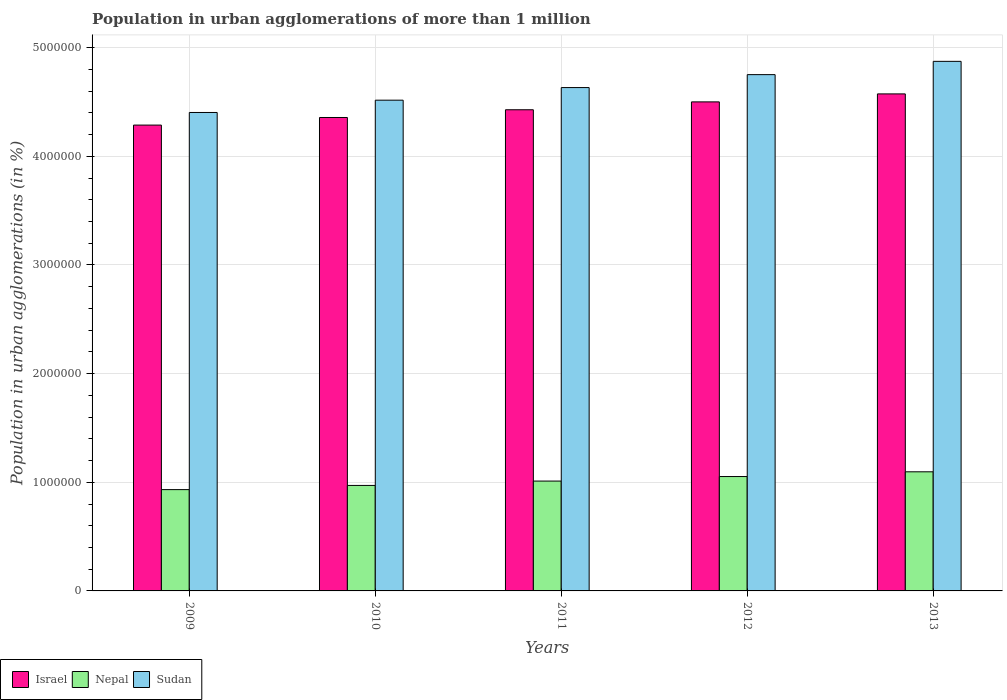How many different coloured bars are there?
Keep it short and to the point. 3. How many groups of bars are there?
Keep it short and to the point. 5. Are the number of bars per tick equal to the number of legend labels?
Offer a very short reply. Yes. What is the label of the 1st group of bars from the left?
Make the answer very short. 2009. In how many cases, is the number of bars for a given year not equal to the number of legend labels?
Your answer should be compact. 0. What is the population in urban agglomerations in Israel in 2010?
Provide a short and direct response. 4.36e+06. Across all years, what is the maximum population in urban agglomerations in Nepal?
Ensure brevity in your answer.  1.10e+06. Across all years, what is the minimum population in urban agglomerations in Israel?
Ensure brevity in your answer.  4.29e+06. In which year was the population in urban agglomerations in Israel maximum?
Offer a terse response. 2013. In which year was the population in urban agglomerations in Nepal minimum?
Offer a terse response. 2009. What is the total population in urban agglomerations in Sudan in the graph?
Make the answer very short. 2.32e+07. What is the difference between the population in urban agglomerations in Sudan in 2011 and that in 2012?
Offer a very short reply. -1.19e+05. What is the difference between the population in urban agglomerations in Israel in 2009 and the population in urban agglomerations in Sudan in 2012?
Your answer should be compact. -4.64e+05. What is the average population in urban agglomerations in Israel per year?
Keep it short and to the point. 4.43e+06. In the year 2012, what is the difference between the population in urban agglomerations in Nepal and population in urban agglomerations in Sudan?
Give a very brief answer. -3.70e+06. What is the ratio of the population in urban agglomerations in Nepal in 2009 to that in 2013?
Make the answer very short. 0.85. Is the population in urban agglomerations in Sudan in 2009 less than that in 2013?
Your answer should be compact. Yes. Is the difference between the population in urban agglomerations in Nepal in 2011 and 2013 greater than the difference between the population in urban agglomerations in Sudan in 2011 and 2013?
Give a very brief answer. Yes. What is the difference between the highest and the second highest population in urban agglomerations in Sudan?
Provide a succinct answer. 1.22e+05. What is the difference between the highest and the lowest population in urban agglomerations in Sudan?
Your response must be concise. 4.71e+05. What does the 2nd bar from the left in 2013 represents?
Offer a terse response. Nepal. Is it the case that in every year, the sum of the population in urban agglomerations in Sudan and population in urban agglomerations in Nepal is greater than the population in urban agglomerations in Israel?
Provide a succinct answer. Yes. How many years are there in the graph?
Provide a succinct answer. 5. What is the difference between two consecutive major ticks on the Y-axis?
Give a very brief answer. 1.00e+06. Does the graph contain any zero values?
Your answer should be very brief. No. Does the graph contain grids?
Provide a short and direct response. Yes. How are the legend labels stacked?
Your answer should be very brief. Horizontal. What is the title of the graph?
Offer a very short reply. Population in urban agglomerations of more than 1 million. What is the label or title of the Y-axis?
Your answer should be compact. Population in urban agglomerations (in %). What is the Population in urban agglomerations (in %) of Israel in 2009?
Offer a very short reply. 4.29e+06. What is the Population in urban agglomerations (in %) of Nepal in 2009?
Provide a short and direct response. 9.32e+05. What is the Population in urban agglomerations (in %) in Sudan in 2009?
Your response must be concise. 4.40e+06. What is the Population in urban agglomerations (in %) in Israel in 2010?
Your answer should be compact. 4.36e+06. What is the Population in urban agglomerations (in %) in Nepal in 2010?
Offer a very short reply. 9.71e+05. What is the Population in urban agglomerations (in %) in Sudan in 2010?
Offer a terse response. 4.52e+06. What is the Population in urban agglomerations (in %) of Israel in 2011?
Make the answer very short. 4.43e+06. What is the Population in urban agglomerations (in %) of Nepal in 2011?
Give a very brief answer. 1.01e+06. What is the Population in urban agglomerations (in %) in Sudan in 2011?
Provide a short and direct response. 4.63e+06. What is the Population in urban agglomerations (in %) of Israel in 2012?
Your response must be concise. 4.50e+06. What is the Population in urban agglomerations (in %) in Nepal in 2012?
Offer a very short reply. 1.05e+06. What is the Population in urban agglomerations (in %) of Sudan in 2012?
Your response must be concise. 4.75e+06. What is the Population in urban agglomerations (in %) of Israel in 2013?
Provide a succinct answer. 4.57e+06. What is the Population in urban agglomerations (in %) of Nepal in 2013?
Provide a short and direct response. 1.10e+06. What is the Population in urban agglomerations (in %) of Sudan in 2013?
Provide a succinct answer. 4.87e+06. Across all years, what is the maximum Population in urban agglomerations (in %) in Israel?
Your response must be concise. 4.57e+06. Across all years, what is the maximum Population in urban agglomerations (in %) of Nepal?
Your response must be concise. 1.10e+06. Across all years, what is the maximum Population in urban agglomerations (in %) of Sudan?
Your answer should be compact. 4.87e+06. Across all years, what is the minimum Population in urban agglomerations (in %) in Israel?
Ensure brevity in your answer.  4.29e+06. Across all years, what is the minimum Population in urban agglomerations (in %) in Nepal?
Your answer should be very brief. 9.32e+05. Across all years, what is the minimum Population in urban agglomerations (in %) in Sudan?
Give a very brief answer. 4.40e+06. What is the total Population in urban agglomerations (in %) of Israel in the graph?
Give a very brief answer. 2.22e+07. What is the total Population in urban agglomerations (in %) of Nepal in the graph?
Offer a terse response. 5.06e+06. What is the total Population in urban agglomerations (in %) of Sudan in the graph?
Make the answer very short. 2.32e+07. What is the difference between the Population in urban agglomerations (in %) in Israel in 2009 and that in 2010?
Your answer should be compact. -6.99e+04. What is the difference between the Population in urban agglomerations (in %) of Nepal in 2009 and that in 2010?
Offer a terse response. -3.85e+04. What is the difference between the Population in urban agglomerations (in %) of Sudan in 2009 and that in 2010?
Make the answer very short. -1.13e+05. What is the difference between the Population in urban agglomerations (in %) of Israel in 2009 and that in 2011?
Make the answer very short. -1.41e+05. What is the difference between the Population in urban agglomerations (in %) of Nepal in 2009 and that in 2011?
Offer a very short reply. -7.87e+04. What is the difference between the Population in urban agglomerations (in %) of Sudan in 2009 and that in 2011?
Provide a short and direct response. -2.29e+05. What is the difference between the Population in urban agglomerations (in %) of Israel in 2009 and that in 2012?
Your answer should be very brief. -2.14e+05. What is the difference between the Population in urban agglomerations (in %) in Nepal in 2009 and that in 2012?
Ensure brevity in your answer.  -1.20e+05. What is the difference between the Population in urban agglomerations (in %) of Sudan in 2009 and that in 2012?
Offer a terse response. -3.48e+05. What is the difference between the Population in urban agglomerations (in %) in Israel in 2009 and that in 2013?
Ensure brevity in your answer.  -2.87e+05. What is the difference between the Population in urban agglomerations (in %) of Nepal in 2009 and that in 2013?
Your response must be concise. -1.64e+05. What is the difference between the Population in urban agglomerations (in %) in Sudan in 2009 and that in 2013?
Keep it short and to the point. -4.71e+05. What is the difference between the Population in urban agglomerations (in %) of Israel in 2010 and that in 2011?
Offer a terse response. -7.11e+04. What is the difference between the Population in urban agglomerations (in %) of Nepal in 2010 and that in 2011?
Make the answer very short. -4.01e+04. What is the difference between the Population in urban agglomerations (in %) in Sudan in 2010 and that in 2011?
Ensure brevity in your answer.  -1.16e+05. What is the difference between the Population in urban agglomerations (in %) in Israel in 2010 and that in 2012?
Ensure brevity in your answer.  -1.44e+05. What is the difference between the Population in urban agglomerations (in %) of Nepal in 2010 and that in 2012?
Your response must be concise. -8.19e+04. What is the difference between the Population in urban agglomerations (in %) in Sudan in 2010 and that in 2012?
Provide a short and direct response. -2.35e+05. What is the difference between the Population in urban agglomerations (in %) in Israel in 2010 and that in 2013?
Keep it short and to the point. -2.17e+05. What is the difference between the Population in urban agglomerations (in %) in Nepal in 2010 and that in 2013?
Give a very brief answer. -1.25e+05. What is the difference between the Population in urban agglomerations (in %) of Sudan in 2010 and that in 2013?
Offer a very short reply. -3.57e+05. What is the difference between the Population in urban agglomerations (in %) of Israel in 2011 and that in 2012?
Provide a succinct answer. -7.24e+04. What is the difference between the Population in urban agglomerations (in %) in Nepal in 2011 and that in 2012?
Your answer should be very brief. -4.18e+04. What is the difference between the Population in urban agglomerations (in %) in Sudan in 2011 and that in 2012?
Offer a terse response. -1.19e+05. What is the difference between the Population in urban agglomerations (in %) in Israel in 2011 and that in 2013?
Your answer should be compact. -1.46e+05. What is the difference between the Population in urban agglomerations (in %) of Nepal in 2011 and that in 2013?
Your answer should be compact. -8.53e+04. What is the difference between the Population in urban agglomerations (in %) in Sudan in 2011 and that in 2013?
Offer a very short reply. -2.41e+05. What is the difference between the Population in urban agglomerations (in %) of Israel in 2012 and that in 2013?
Offer a very short reply. -7.35e+04. What is the difference between the Population in urban agglomerations (in %) in Nepal in 2012 and that in 2013?
Your answer should be very brief. -4.35e+04. What is the difference between the Population in urban agglomerations (in %) of Sudan in 2012 and that in 2013?
Keep it short and to the point. -1.22e+05. What is the difference between the Population in urban agglomerations (in %) of Israel in 2009 and the Population in urban agglomerations (in %) of Nepal in 2010?
Make the answer very short. 3.32e+06. What is the difference between the Population in urban agglomerations (in %) in Israel in 2009 and the Population in urban agglomerations (in %) in Sudan in 2010?
Provide a succinct answer. -2.29e+05. What is the difference between the Population in urban agglomerations (in %) in Nepal in 2009 and the Population in urban agglomerations (in %) in Sudan in 2010?
Your answer should be very brief. -3.58e+06. What is the difference between the Population in urban agglomerations (in %) of Israel in 2009 and the Population in urban agglomerations (in %) of Nepal in 2011?
Your response must be concise. 3.28e+06. What is the difference between the Population in urban agglomerations (in %) in Israel in 2009 and the Population in urban agglomerations (in %) in Sudan in 2011?
Your response must be concise. -3.45e+05. What is the difference between the Population in urban agglomerations (in %) of Nepal in 2009 and the Population in urban agglomerations (in %) of Sudan in 2011?
Provide a succinct answer. -3.70e+06. What is the difference between the Population in urban agglomerations (in %) in Israel in 2009 and the Population in urban agglomerations (in %) in Nepal in 2012?
Give a very brief answer. 3.23e+06. What is the difference between the Population in urban agglomerations (in %) of Israel in 2009 and the Population in urban agglomerations (in %) of Sudan in 2012?
Ensure brevity in your answer.  -4.64e+05. What is the difference between the Population in urban agglomerations (in %) of Nepal in 2009 and the Population in urban agglomerations (in %) of Sudan in 2012?
Ensure brevity in your answer.  -3.82e+06. What is the difference between the Population in urban agglomerations (in %) of Israel in 2009 and the Population in urban agglomerations (in %) of Nepal in 2013?
Ensure brevity in your answer.  3.19e+06. What is the difference between the Population in urban agglomerations (in %) of Israel in 2009 and the Population in urban agglomerations (in %) of Sudan in 2013?
Provide a short and direct response. -5.87e+05. What is the difference between the Population in urban agglomerations (in %) of Nepal in 2009 and the Population in urban agglomerations (in %) of Sudan in 2013?
Keep it short and to the point. -3.94e+06. What is the difference between the Population in urban agglomerations (in %) of Israel in 2010 and the Population in urban agglomerations (in %) of Nepal in 2011?
Your answer should be very brief. 3.35e+06. What is the difference between the Population in urban agglomerations (in %) of Israel in 2010 and the Population in urban agglomerations (in %) of Sudan in 2011?
Offer a very short reply. -2.75e+05. What is the difference between the Population in urban agglomerations (in %) in Nepal in 2010 and the Population in urban agglomerations (in %) in Sudan in 2011?
Give a very brief answer. -3.66e+06. What is the difference between the Population in urban agglomerations (in %) of Israel in 2010 and the Population in urban agglomerations (in %) of Nepal in 2012?
Provide a succinct answer. 3.30e+06. What is the difference between the Population in urban agglomerations (in %) of Israel in 2010 and the Population in urban agglomerations (in %) of Sudan in 2012?
Keep it short and to the point. -3.95e+05. What is the difference between the Population in urban agglomerations (in %) of Nepal in 2010 and the Population in urban agglomerations (in %) of Sudan in 2012?
Provide a succinct answer. -3.78e+06. What is the difference between the Population in urban agglomerations (in %) of Israel in 2010 and the Population in urban agglomerations (in %) of Nepal in 2013?
Offer a very short reply. 3.26e+06. What is the difference between the Population in urban agglomerations (in %) in Israel in 2010 and the Population in urban agglomerations (in %) in Sudan in 2013?
Your response must be concise. -5.17e+05. What is the difference between the Population in urban agglomerations (in %) in Nepal in 2010 and the Population in urban agglomerations (in %) in Sudan in 2013?
Make the answer very short. -3.90e+06. What is the difference between the Population in urban agglomerations (in %) in Israel in 2011 and the Population in urban agglomerations (in %) in Nepal in 2012?
Your response must be concise. 3.38e+06. What is the difference between the Population in urban agglomerations (in %) in Israel in 2011 and the Population in urban agglomerations (in %) in Sudan in 2012?
Provide a succinct answer. -3.23e+05. What is the difference between the Population in urban agglomerations (in %) in Nepal in 2011 and the Population in urban agglomerations (in %) in Sudan in 2012?
Your answer should be very brief. -3.74e+06. What is the difference between the Population in urban agglomerations (in %) in Israel in 2011 and the Population in urban agglomerations (in %) in Nepal in 2013?
Provide a succinct answer. 3.33e+06. What is the difference between the Population in urban agglomerations (in %) in Israel in 2011 and the Population in urban agglomerations (in %) in Sudan in 2013?
Offer a terse response. -4.46e+05. What is the difference between the Population in urban agglomerations (in %) in Nepal in 2011 and the Population in urban agglomerations (in %) in Sudan in 2013?
Ensure brevity in your answer.  -3.86e+06. What is the difference between the Population in urban agglomerations (in %) of Israel in 2012 and the Population in urban agglomerations (in %) of Nepal in 2013?
Offer a very short reply. 3.40e+06. What is the difference between the Population in urban agglomerations (in %) of Israel in 2012 and the Population in urban agglomerations (in %) of Sudan in 2013?
Offer a very short reply. -3.73e+05. What is the difference between the Population in urban agglomerations (in %) of Nepal in 2012 and the Population in urban agglomerations (in %) of Sudan in 2013?
Keep it short and to the point. -3.82e+06. What is the average Population in urban agglomerations (in %) in Israel per year?
Keep it short and to the point. 4.43e+06. What is the average Population in urban agglomerations (in %) of Nepal per year?
Make the answer very short. 1.01e+06. What is the average Population in urban agglomerations (in %) in Sudan per year?
Give a very brief answer. 4.64e+06. In the year 2009, what is the difference between the Population in urban agglomerations (in %) of Israel and Population in urban agglomerations (in %) of Nepal?
Give a very brief answer. 3.36e+06. In the year 2009, what is the difference between the Population in urban agglomerations (in %) in Israel and Population in urban agglomerations (in %) in Sudan?
Provide a short and direct response. -1.16e+05. In the year 2009, what is the difference between the Population in urban agglomerations (in %) of Nepal and Population in urban agglomerations (in %) of Sudan?
Offer a very short reply. -3.47e+06. In the year 2010, what is the difference between the Population in urban agglomerations (in %) in Israel and Population in urban agglomerations (in %) in Nepal?
Your response must be concise. 3.39e+06. In the year 2010, what is the difference between the Population in urban agglomerations (in %) of Israel and Population in urban agglomerations (in %) of Sudan?
Offer a very short reply. -1.59e+05. In the year 2010, what is the difference between the Population in urban agglomerations (in %) in Nepal and Population in urban agglomerations (in %) in Sudan?
Your answer should be compact. -3.55e+06. In the year 2011, what is the difference between the Population in urban agglomerations (in %) of Israel and Population in urban agglomerations (in %) of Nepal?
Your response must be concise. 3.42e+06. In the year 2011, what is the difference between the Population in urban agglomerations (in %) in Israel and Population in urban agglomerations (in %) in Sudan?
Keep it short and to the point. -2.04e+05. In the year 2011, what is the difference between the Population in urban agglomerations (in %) of Nepal and Population in urban agglomerations (in %) of Sudan?
Make the answer very short. -3.62e+06. In the year 2012, what is the difference between the Population in urban agglomerations (in %) of Israel and Population in urban agglomerations (in %) of Nepal?
Make the answer very short. 3.45e+06. In the year 2012, what is the difference between the Population in urban agglomerations (in %) of Israel and Population in urban agglomerations (in %) of Sudan?
Your answer should be compact. -2.51e+05. In the year 2012, what is the difference between the Population in urban agglomerations (in %) in Nepal and Population in urban agglomerations (in %) in Sudan?
Ensure brevity in your answer.  -3.70e+06. In the year 2013, what is the difference between the Population in urban agglomerations (in %) in Israel and Population in urban agglomerations (in %) in Nepal?
Provide a short and direct response. 3.48e+06. In the year 2013, what is the difference between the Population in urban agglomerations (in %) of Israel and Population in urban agglomerations (in %) of Sudan?
Your response must be concise. -3.00e+05. In the year 2013, what is the difference between the Population in urban agglomerations (in %) of Nepal and Population in urban agglomerations (in %) of Sudan?
Provide a succinct answer. -3.78e+06. What is the ratio of the Population in urban agglomerations (in %) of Israel in 2009 to that in 2010?
Keep it short and to the point. 0.98. What is the ratio of the Population in urban agglomerations (in %) of Nepal in 2009 to that in 2010?
Your answer should be compact. 0.96. What is the ratio of the Population in urban agglomerations (in %) of Sudan in 2009 to that in 2010?
Ensure brevity in your answer.  0.97. What is the ratio of the Population in urban agglomerations (in %) in Israel in 2009 to that in 2011?
Keep it short and to the point. 0.97. What is the ratio of the Population in urban agglomerations (in %) in Nepal in 2009 to that in 2011?
Offer a very short reply. 0.92. What is the ratio of the Population in urban agglomerations (in %) of Sudan in 2009 to that in 2011?
Your answer should be very brief. 0.95. What is the ratio of the Population in urban agglomerations (in %) in Israel in 2009 to that in 2012?
Offer a terse response. 0.95. What is the ratio of the Population in urban agglomerations (in %) of Nepal in 2009 to that in 2012?
Provide a succinct answer. 0.89. What is the ratio of the Population in urban agglomerations (in %) in Sudan in 2009 to that in 2012?
Provide a short and direct response. 0.93. What is the ratio of the Population in urban agglomerations (in %) in Israel in 2009 to that in 2013?
Ensure brevity in your answer.  0.94. What is the ratio of the Population in urban agglomerations (in %) in Nepal in 2009 to that in 2013?
Keep it short and to the point. 0.85. What is the ratio of the Population in urban agglomerations (in %) in Sudan in 2009 to that in 2013?
Your response must be concise. 0.9. What is the ratio of the Population in urban agglomerations (in %) in Israel in 2010 to that in 2011?
Provide a short and direct response. 0.98. What is the ratio of the Population in urban agglomerations (in %) in Nepal in 2010 to that in 2011?
Ensure brevity in your answer.  0.96. What is the ratio of the Population in urban agglomerations (in %) of Sudan in 2010 to that in 2011?
Keep it short and to the point. 0.97. What is the ratio of the Population in urban agglomerations (in %) in Israel in 2010 to that in 2012?
Provide a succinct answer. 0.97. What is the ratio of the Population in urban agglomerations (in %) in Nepal in 2010 to that in 2012?
Give a very brief answer. 0.92. What is the ratio of the Population in urban agglomerations (in %) in Sudan in 2010 to that in 2012?
Keep it short and to the point. 0.95. What is the ratio of the Population in urban agglomerations (in %) of Israel in 2010 to that in 2013?
Ensure brevity in your answer.  0.95. What is the ratio of the Population in urban agglomerations (in %) of Nepal in 2010 to that in 2013?
Give a very brief answer. 0.89. What is the ratio of the Population in urban agglomerations (in %) of Sudan in 2010 to that in 2013?
Provide a short and direct response. 0.93. What is the ratio of the Population in urban agglomerations (in %) in Israel in 2011 to that in 2012?
Provide a succinct answer. 0.98. What is the ratio of the Population in urban agglomerations (in %) in Nepal in 2011 to that in 2012?
Keep it short and to the point. 0.96. What is the ratio of the Population in urban agglomerations (in %) in Sudan in 2011 to that in 2012?
Ensure brevity in your answer.  0.97. What is the ratio of the Population in urban agglomerations (in %) in Israel in 2011 to that in 2013?
Offer a very short reply. 0.97. What is the ratio of the Population in urban agglomerations (in %) in Nepal in 2011 to that in 2013?
Offer a terse response. 0.92. What is the ratio of the Population in urban agglomerations (in %) of Sudan in 2011 to that in 2013?
Provide a succinct answer. 0.95. What is the ratio of the Population in urban agglomerations (in %) of Israel in 2012 to that in 2013?
Keep it short and to the point. 0.98. What is the ratio of the Population in urban agglomerations (in %) of Nepal in 2012 to that in 2013?
Offer a terse response. 0.96. What is the ratio of the Population in urban agglomerations (in %) in Sudan in 2012 to that in 2013?
Keep it short and to the point. 0.97. What is the difference between the highest and the second highest Population in urban agglomerations (in %) of Israel?
Give a very brief answer. 7.35e+04. What is the difference between the highest and the second highest Population in urban agglomerations (in %) of Nepal?
Ensure brevity in your answer.  4.35e+04. What is the difference between the highest and the second highest Population in urban agglomerations (in %) in Sudan?
Offer a very short reply. 1.22e+05. What is the difference between the highest and the lowest Population in urban agglomerations (in %) of Israel?
Your answer should be compact. 2.87e+05. What is the difference between the highest and the lowest Population in urban agglomerations (in %) of Nepal?
Keep it short and to the point. 1.64e+05. What is the difference between the highest and the lowest Population in urban agglomerations (in %) of Sudan?
Provide a short and direct response. 4.71e+05. 